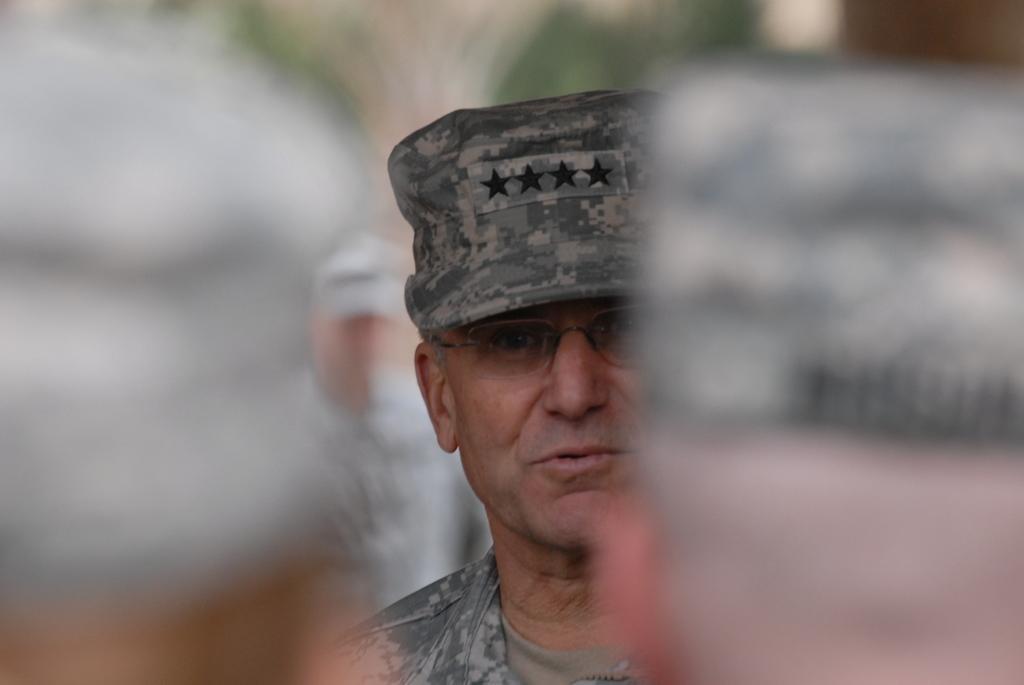Please provide a concise description of this image. In this picture we can see four persons, a man in the middle wore a cap and spectacles, there is a blurry background. 